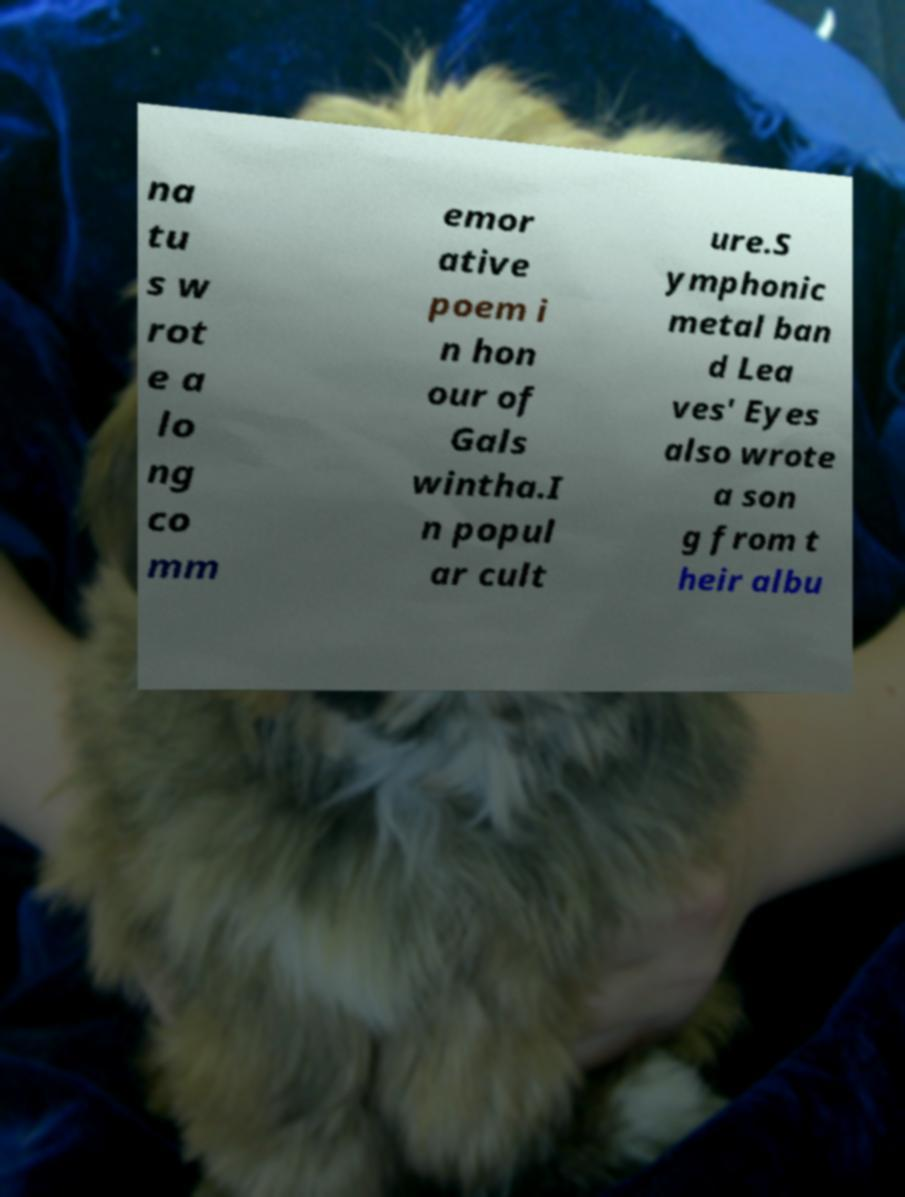Please identify and transcribe the text found in this image. na tu s w rot e a lo ng co mm emor ative poem i n hon our of Gals wintha.I n popul ar cult ure.S ymphonic metal ban d Lea ves' Eyes also wrote a son g from t heir albu 